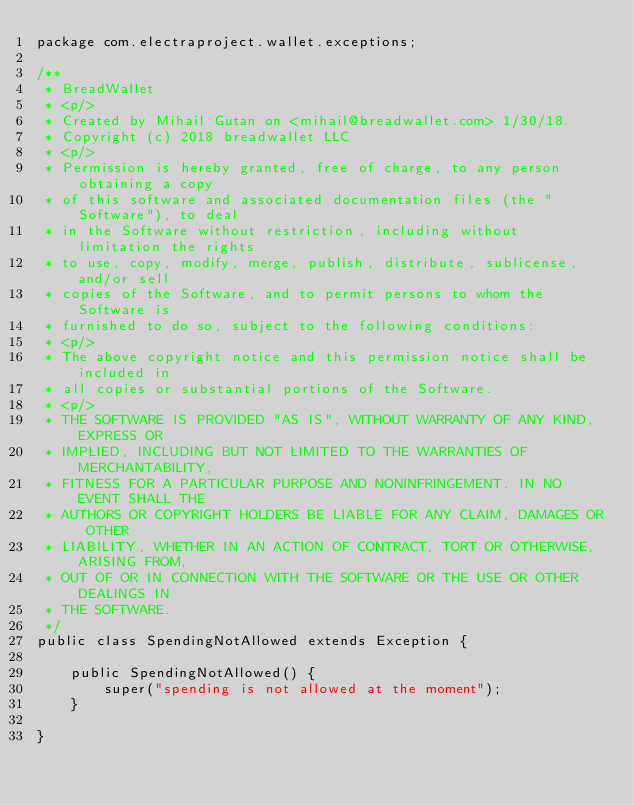Convert code to text. <code><loc_0><loc_0><loc_500><loc_500><_Java_>package com.electraproject.wallet.exceptions;

/**
 * BreadWallet
 * <p/>
 * Created by Mihail Gutan on <mihail@breadwallet.com> 1/30/18.
 * Copyright (c) 2018 breadwallet LLC
 * <p/>
 * Permission is hereby granted, free of charge, to any person obtaining a copy
 * of this software and associated documentation files (the "Software"), to deal
 * in the Software without restriction, including without limitation the rights
 * to use, copy, modify, merge, publish, distribute, sublicense, and/or sell
 * copies of the Software, and to permit persons to whom the Software is
 * furnished to do so, subject to the following conditions:
 * <p/>
 * The above copyright notice and this permission notice shall be included in
 * all copies or substantial portions of the Software.
 * <p/>
 * THE SOFTWARE IS PROVIDED "AS IS", WITHOUT WARRANTY OF ANY KIND, EXPRESS OR
 * IMPLIED, INCLUDING BUT NOT LIMITED TO THE WARRANTIES OF MERCHANTABILITY,
 * FITNESS FOR A PARTICULAR PURPOSE AND NONINFRINGEMENT. IN NO EVENT SHALL THE
 * AUTHORS OR COPYRIGHT HOLDERS BE LIABLE FOR ANY CLAIM, DAMAGES OR OTHER
 * LIABILITY, WHETHER IN AN ACTION OF CONTRACT, TORT OR OTHERWISE, ARISING FROM,
 * OUT OF OR IN CONNECTION WITH THE SOFTWARE OR THE USE OR OTHER DEALINGS IN
 * THE SOFTWARE.
 */
public class SpendingNotAllowed extends Exception {

    public SpendingNotAllowed() {
        super("spending is not allowed at the moment");
    }

}</code> 